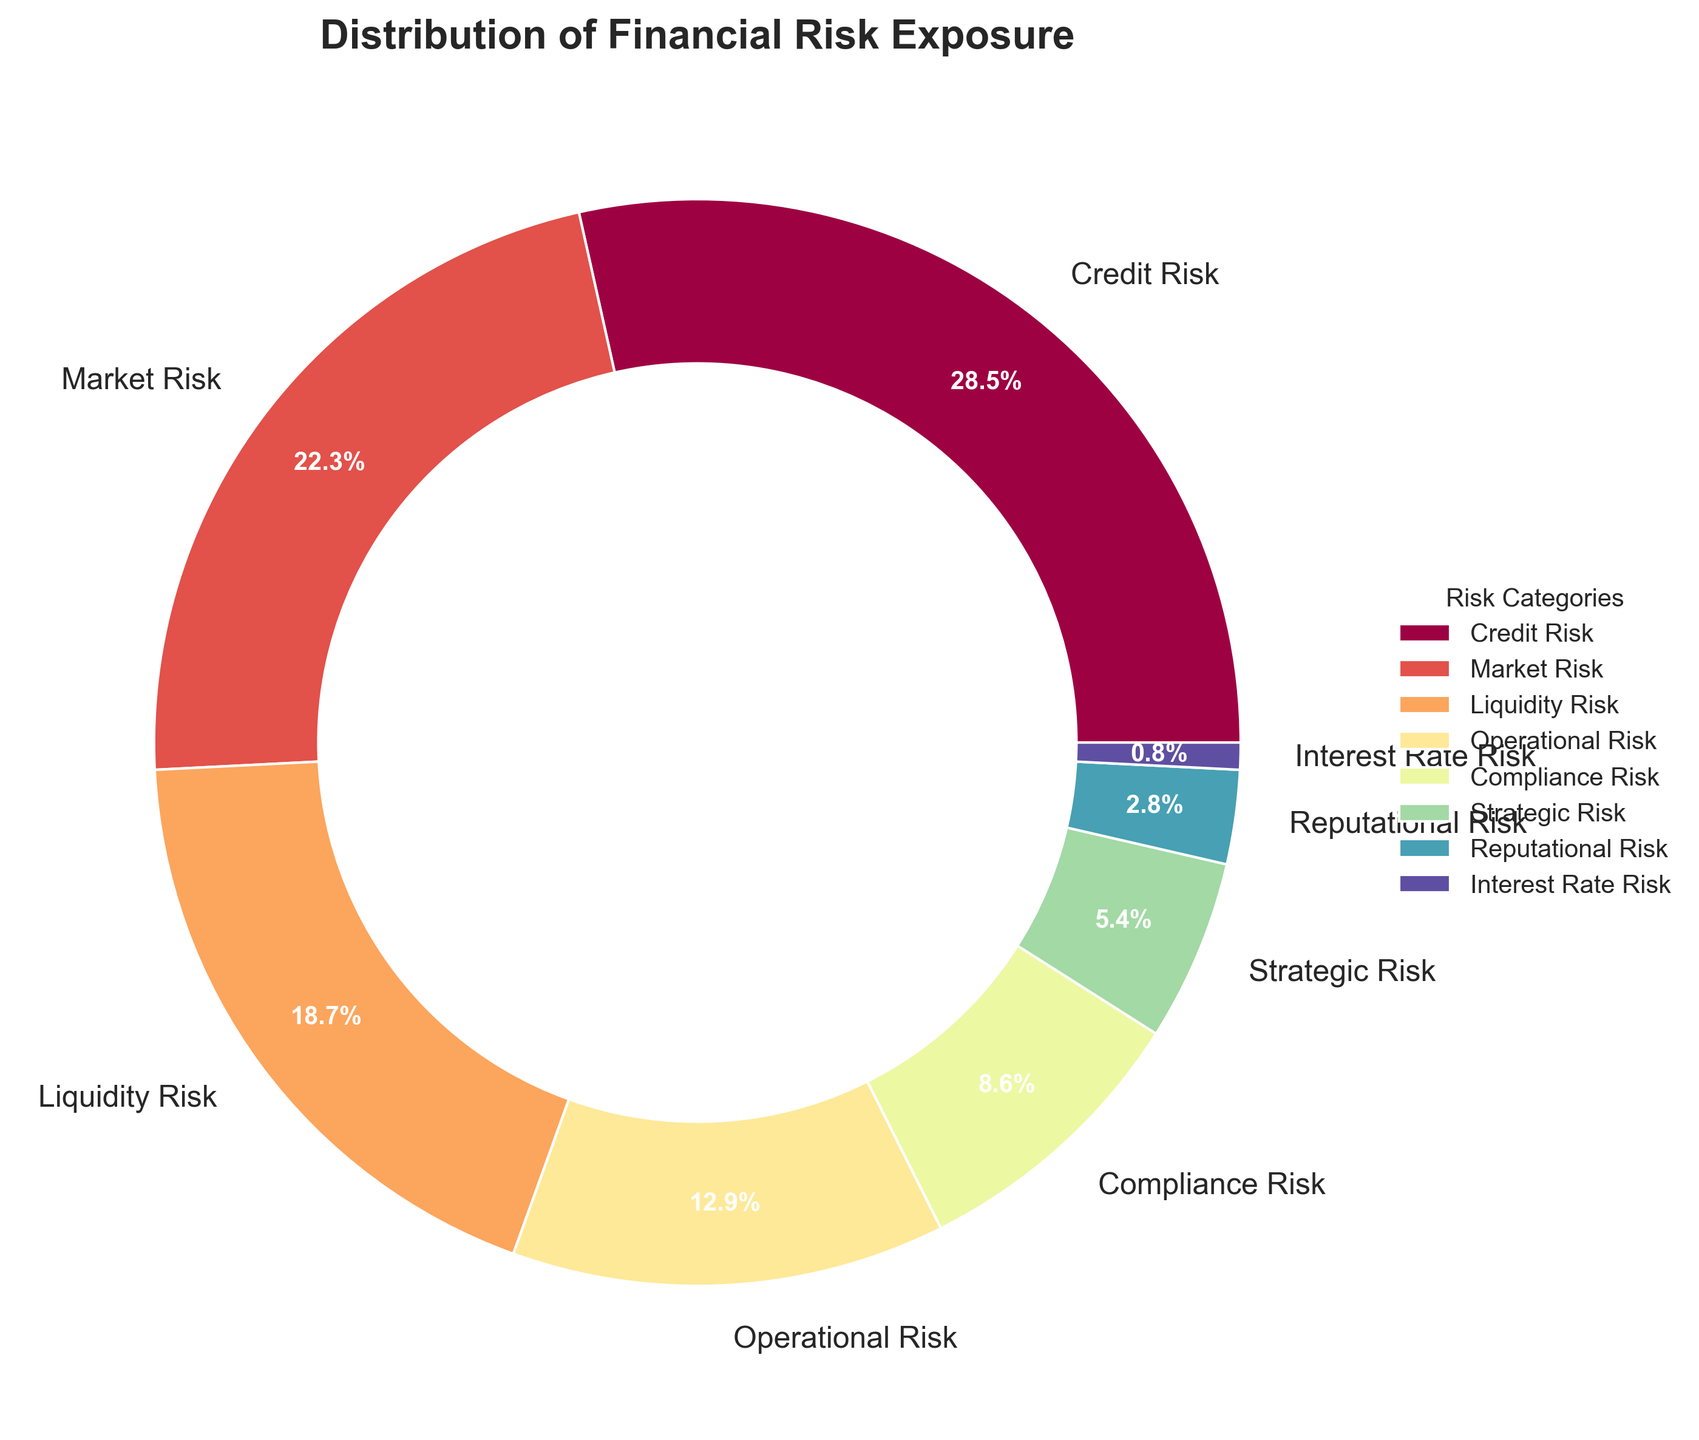Which risk category has the highest percentage of financial risk exposure? Refer to the pie chart and identify the category with the largest segment. This is the category with the highest percentage.
Answer: Credit Risk Which two risk categories together account for more than 50% of the financial risk exposure? Sum the percentages of the top categories. Credit Risk (28.5%) + Market Risk (22.3%) > 50%.
Answer: Credit Risk and Market Risk What is the combined percentage of Operational Risk and Compliance Risk? Add the percentages of Operational Risk (12.9%) and Compliance Risk (8.6%).
Answer: 21.5% How does the exposure of Market Risk compare to Liquidity Risk? Compare the percentages of Market Risk (22.3%) and Liquidity Risk (18.7%). Market Risk has a higher percentage.
Answer: Market Risk is greater Which risk category has the smallest percentage of financial risk exposure? Look for the category with the smallest segment. This is the category with the lowest percentage.
Answer: Interest Rate Risk What is the difference in percentage between Credit Risk and Market Risk? Subtract the percentage of Market Risk (22.3%) from the percentage of Credit Risk (28.5%).
Answer: 6.2 What percentage of financial risk exposure is covered by Strategic Risk and Reputational Risk combined? Add the percentages of Strategic Risk (5.4%) and Reputational Risk (2.8%).
Answer: 8.2% Is the exposure to Compliance Risk greater than that to Strategic Risk? Compare the percentages of Compliance Risk (8.6%) and Strategic Risk (5.4%). Compliance Risk is higher.
Answer: Yes By what factor is the exposure of Operational Risk greater than Reputational Risk? Divide the percentage of Operational Risk (12.9%) by the percentage of Reputational Risk (2.8%).
Answer: About 4.6 Which three risk categories make up the largest portions of financial risk exposure? Identify the three largest segments from the chart: Credit Risk (28.5%), Market Risk (22.3%), and Liquidity Risk (18.7%).
Answer: Credit Risk, Market Risk, Liquidity Risk 